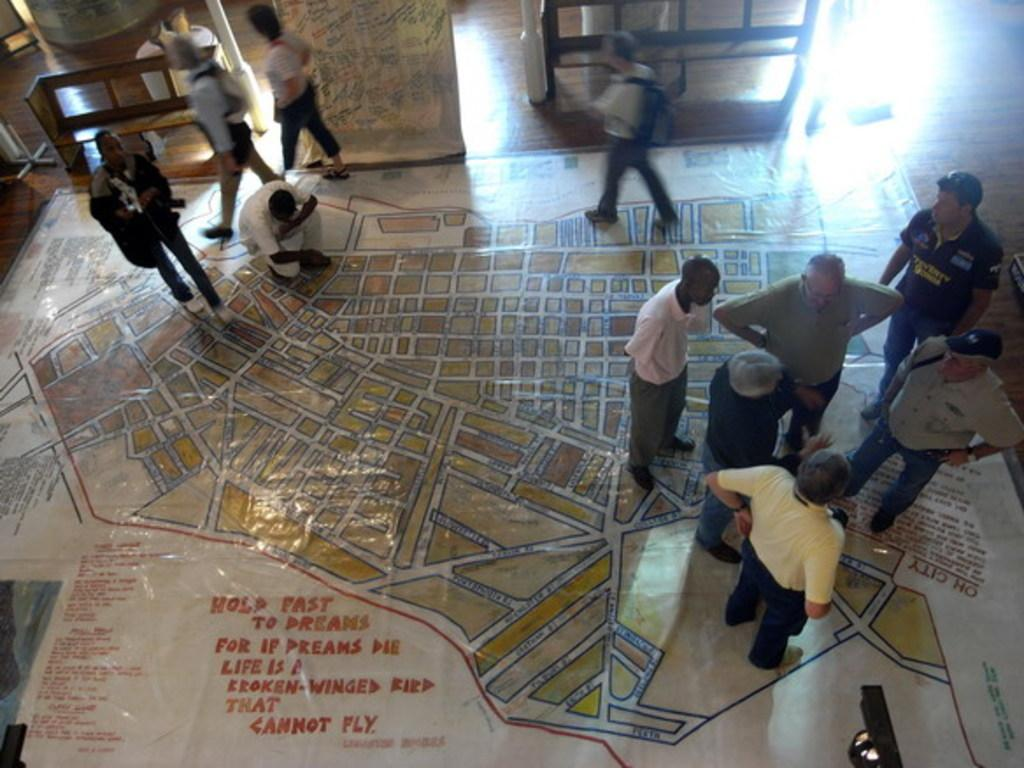What are the people in the image doing on the polythene sheet? There are people standing on a polythene sheet in the image. Is anyone sitting on the polythene sheet? Yes, one person is sitting on the polythene sheet. What can be seen in the background of the image? There are benches and walls in the background of the image. What type of kettle is being used to join the people together in the image? There is no kettle present in the image, and the people are not being joined together. 